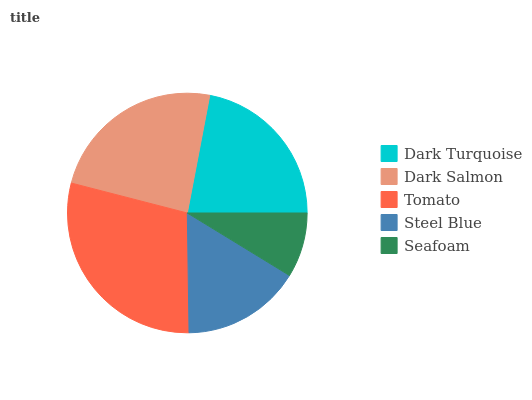Is Seafoam the minimum?
Answer yes or no. Yes. Is Tomato the maximum?
Answer yes or no. Yes. Is Dark Salmon the minimum?
Answer yes or no. No. Is Dark Salmon the maximum?
Answer yes or no. No. Is Dark Salmon greater than Dark Turquoise?
Answer yes or no. Yes. Is Dark Turquoise less than Dark Salmon?
Answer yes or no. Yes. Is Dark Turquoise greater than Dark Salmon?
Answer yes or no. No. Is Dark Salmon less than Dark Turquoise?
Answer yes or no. No. Is Dark Turquoise the high median?
Answer yes or no. Yes. Is Dark Turquoise the low median?
Answer yes or no. Yes. Is Steel Blue the high median?
Answer yes or no. No. Is Steel Blue the low median?
Answer yes or no. No. 